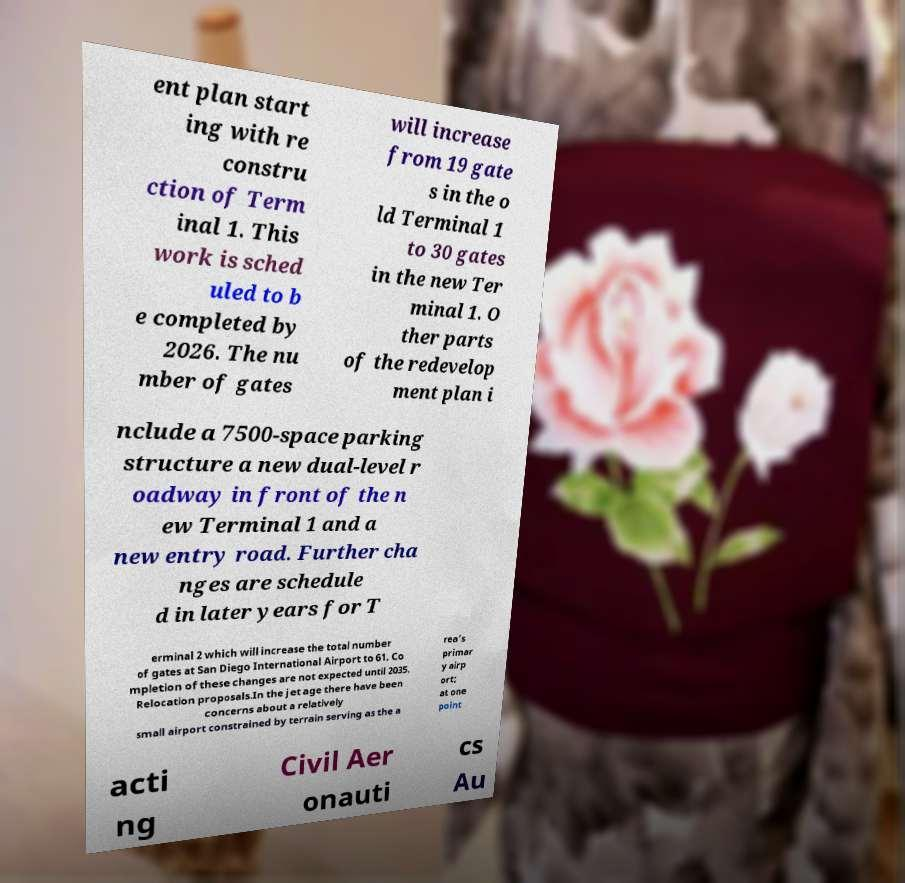Please read and relay the text visible in this image. What does it say? ent plan start ing with re constru ction of Term inal 1. This work is sched uled to b e completed by 2026. The nu mber of gates will increase from 19 gate s in the o ld Terminal 1 to 30 gates in the new Ter minal 1. O ther parts of the redevelop ment plan i nclude a 7500-space parking structure a new dual-level r oadway in front of the n ew Terminal 1 and a new entry road. Further cha nges are schedule d in later years for T erminal 2 which will increase the total number of gates at San Diego International Airport to 61. Co mpletion of these changes are not expected until 2035. Relocation proposals.In the jet age there have been concerns about a relatively small airport constrained by terrain serving as the a rea's primar y airp ort; at one point acti ng Civil Aer onauti cs Au 